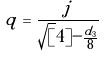Convert formula to latex. <formula><loc_0><loc_0><loc_500><loc_500>q = \frac { j } { \sqrt { [ } 4 ] { - \frac { d _ { 3 } } { 8 } } }</formula> 